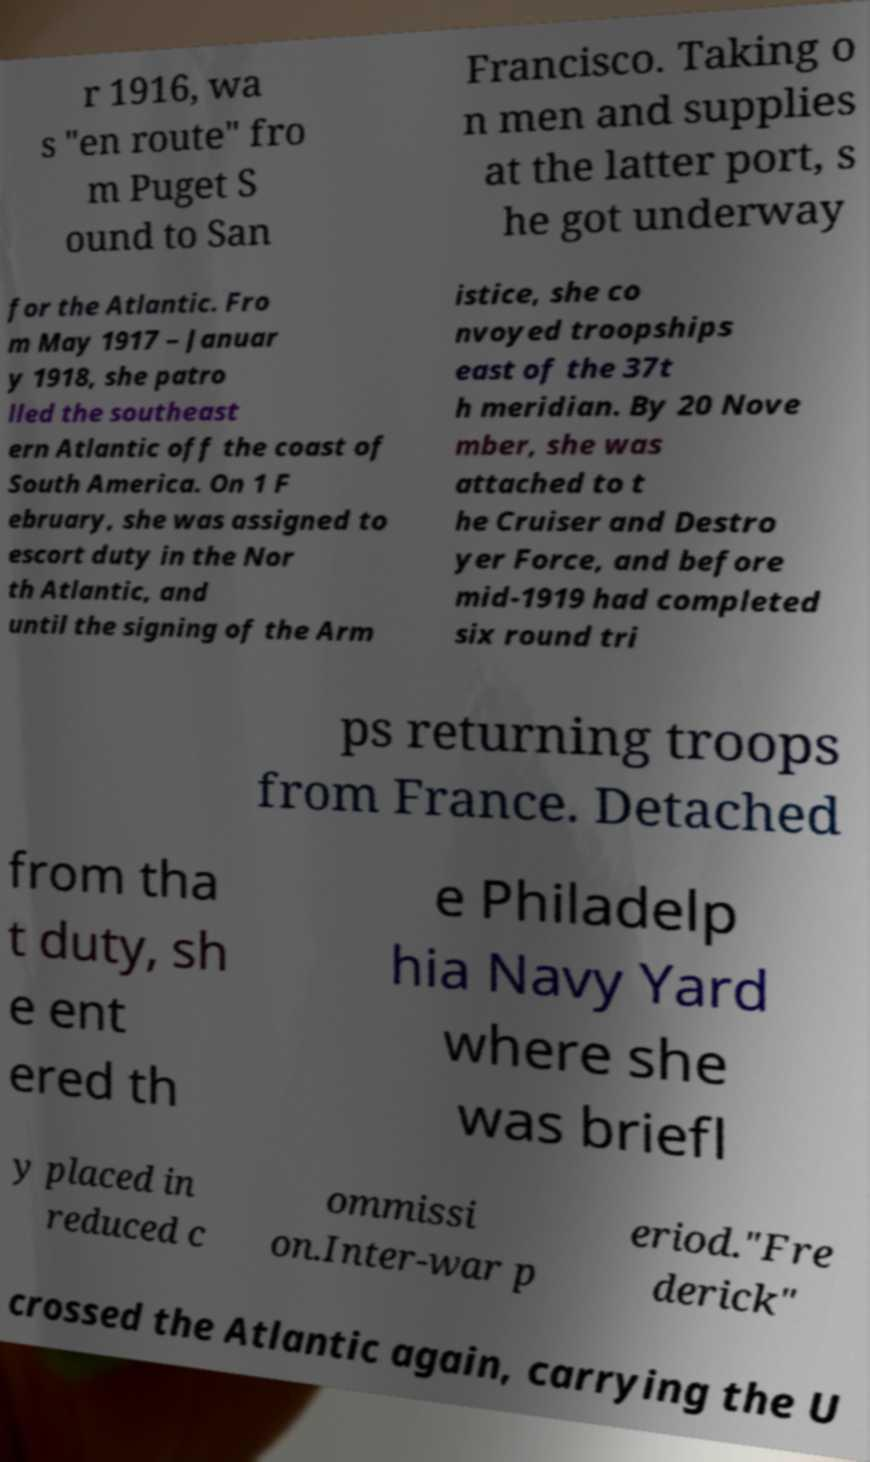Can you accurately transcribe the text from the provided image for me? r 1916, wa s "en route" fro m Puget S ound to San Francisco. Taking o n men and supplies at the latter port, s he got underway for the Atlantic. Fro m May 1917 – Januar y 1918, she patro lled the southeast ern Atlantic off the coast of South America. On 1 F ebruary, she was assigned to escort duty in the Nor th Atlantic, and until the signing of the Arm istice, she co nvoyed troopships east of the 37t h meridian. By 20 Nove mber, she was attached to t he Cruiser and Destro yer Force, and before mid-1919 had completed six round tri ps returning troops from France. Detached from tha t duty, sh e ent ered th e Philadelp hia Navy Yard where she was briefl y placed in reduced c ommissi on.Inter-war p eriod."Fre derick" crossed the Atlantic again, carrying the U 